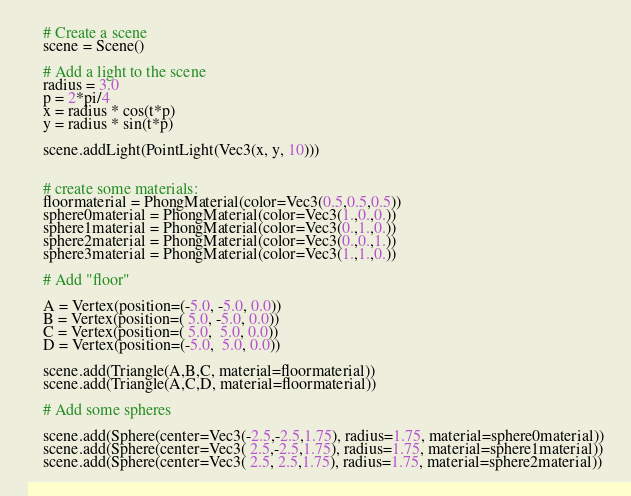Convert code to text. <code><loc_0><loc_0><loc_500><loc_500><_Python_>    # Create a scene
    scene = Scene()

    # Add a light to the scene
    radius = 3.0
    p = 2*pi/4
    x = radius * cos(t*p)
    y = radius * sin(t*p)

    scene.addLight(PointLight(Vec3(x, y, 10)))


    # create some materials:
    floormaterial = PhongMaterial(color=Vec3(0.5,0.5,0.5))
    sphere0material = PhongMaterial(color=Vec3(1.,0.,0.))
    sphere1material = PhongMaterial(color=Vec3(0.,1.,0.))
    sphere2material = PhongMaterial(color=Vec3(0.,0.,1.))
    sphere3material = PhongMaterial(color=Vec3(1.,1.,0.))

    # Add "floor"

    A = Vertex(position=(-5.0, -5.0, 0.0))
    B = Vertex(position=( 5.0, -5.0, 0.0))
    C = Vertex(position=( 5.0,  5.0, 0.0))
    D = Vertex(position=(-5.0,  5.0, 0.0))

    scene.add(Triangle(A,B,C, material=floormaterial))
    scene.add(Triangle(A,C,D, material=floormaterial))

    # Add some spheres

    scene.add(Sphere(center=Vec3(-2.5,-2.5,1.75), radius=1.75, material=sphere0material))
    scene.add(Sphere(center=Vec3( 2.5,-2.5,1.75), radius=1.75, material=sphere1material))
    scene.add(Sphere(center=Vec3( 2.5, 2.5,1.75), radius=1.75, material=sphere2material))</code> 